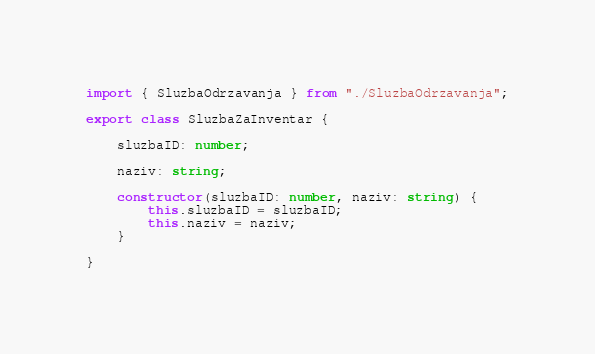Convert code to text. <code><loc_0><loc_0><loc_500><loc_500><_TypeScript_>import { SluzbaOdrzavanja } from "./SluzbaOdrzavanja";

export class SluzbaZaInventar {

    sluzbaID: number;

    naziv: string;
	
    constructor(sluzbaID: number, naziv: string) {
        this.sluzbaID = sluzbaID;
        this.naziv = naziv;
    }
	
}</code> 